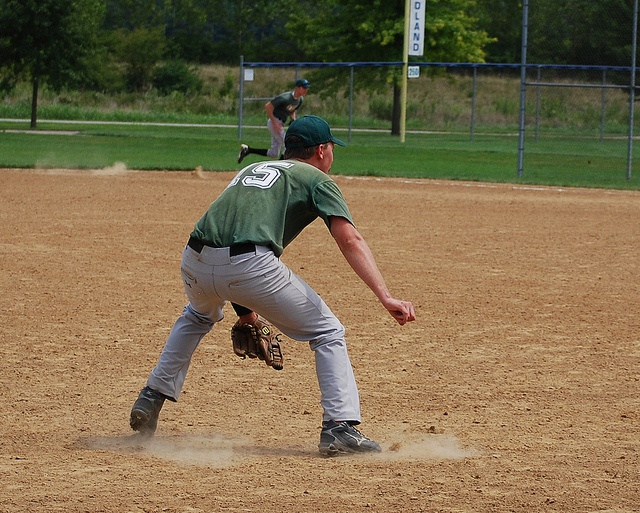Describe the objects in this image and their specific colors. I can see people in black, gray, darkgray, and maroon tones, baseball glove in black, maroon, gray, and tan tones, and people in black, gray, and maroon tones in this image. 